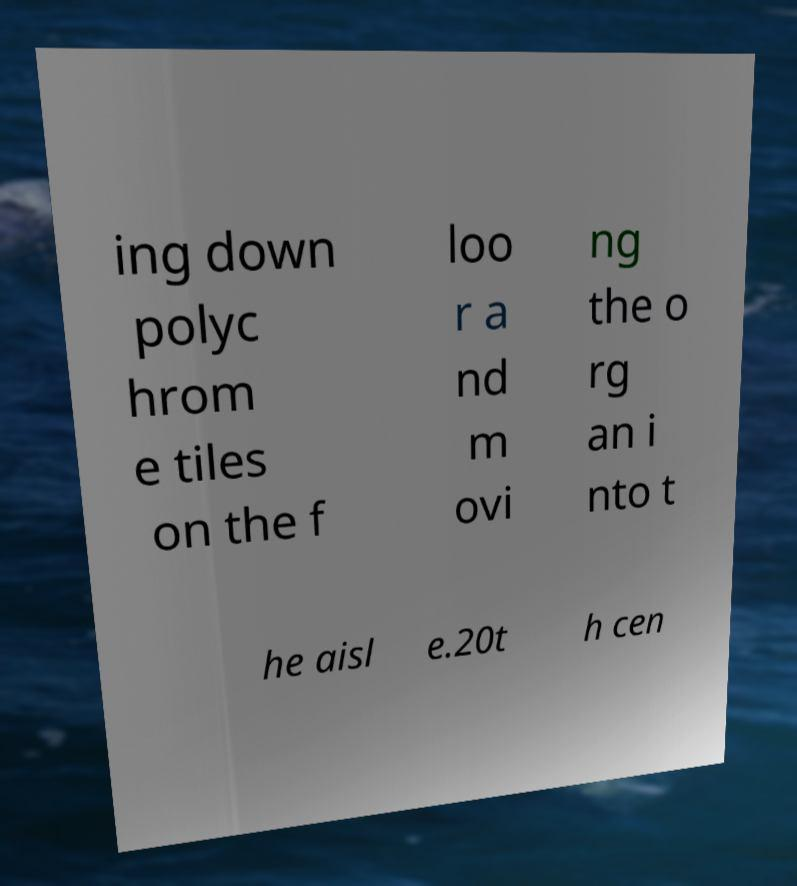Can you read and provide the text displayed in the image?This photo seems to have some interesting text. Can you extract and type it out for me? ing down polyc hrom e tiles on the f loo r a nd m ovi ng the o rg an i nto t he aisl e.20t h cen 